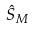Convert formula to latex. <formula><loc_0><loc_0><loc_500><loc_500>\hat { S } _ { M }</formula> 